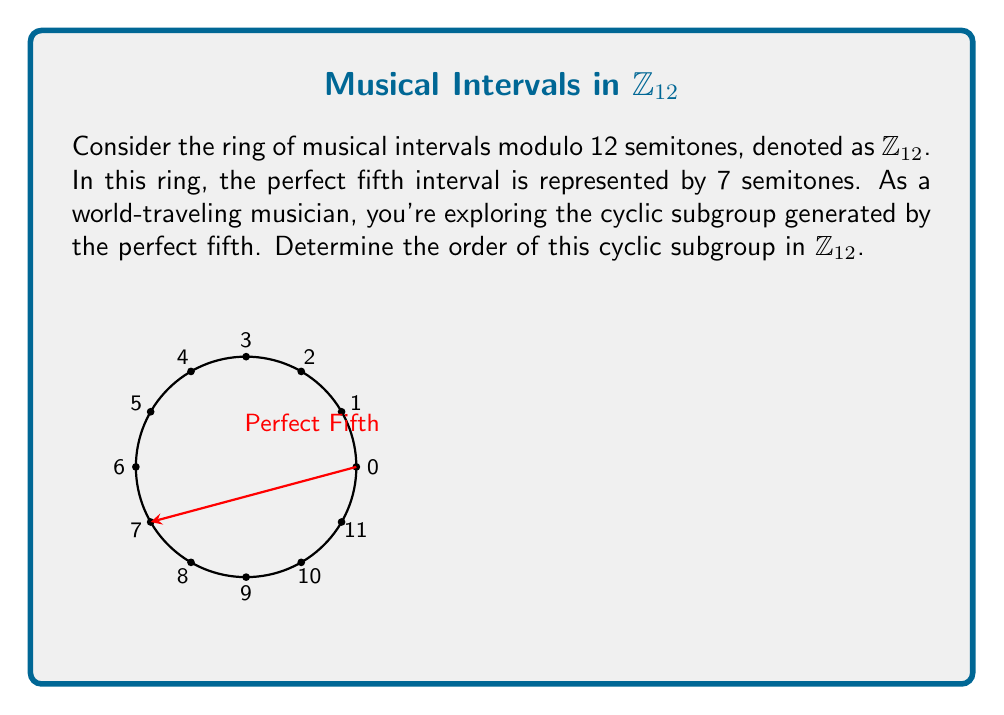Teach me how to tackle this problem. Let's approach this step-by-step:

1) In $\mathbb{Z}_{12}$, the perfect fifth is represented by 7 semitones. We need to find the order of the cyclic subgroup generated by 7.

2) To do this, we'll compute the powers of 7 modulo 12 until we get back to 0:

   $7^1 \equiv 7 \pmod{12}$
   $7^2 \equiv 1 \pmod{12}$ (because $7 \cdot 7 = 49 \equiv 1 \pmod{12}$)

3) We've returned to 1 after two steps. This means that the cyclic subgroup generated by 7 has order 2.

4) Musically, this corresponds to the fact that if you go up by a perfect fifth twice, you end up an octave above where you started (plus one semitone).

5) We can verify this by looking at the elements in this subgroup:
   $\{0, 7\}$

   Indeed, these are the only distinct elements generated by repeatedly adding 7 in $\mathbb{Z}_{12}$.

6) This subgroup structure is related to the circle of fifths in music theory, which is foundational in Western music and present in many world music traditions.
Answer: 2 